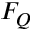Convert formula to latex. <formula><loc_0><loc_0><loc_500><loc_500>F _ { Q }</formula> 